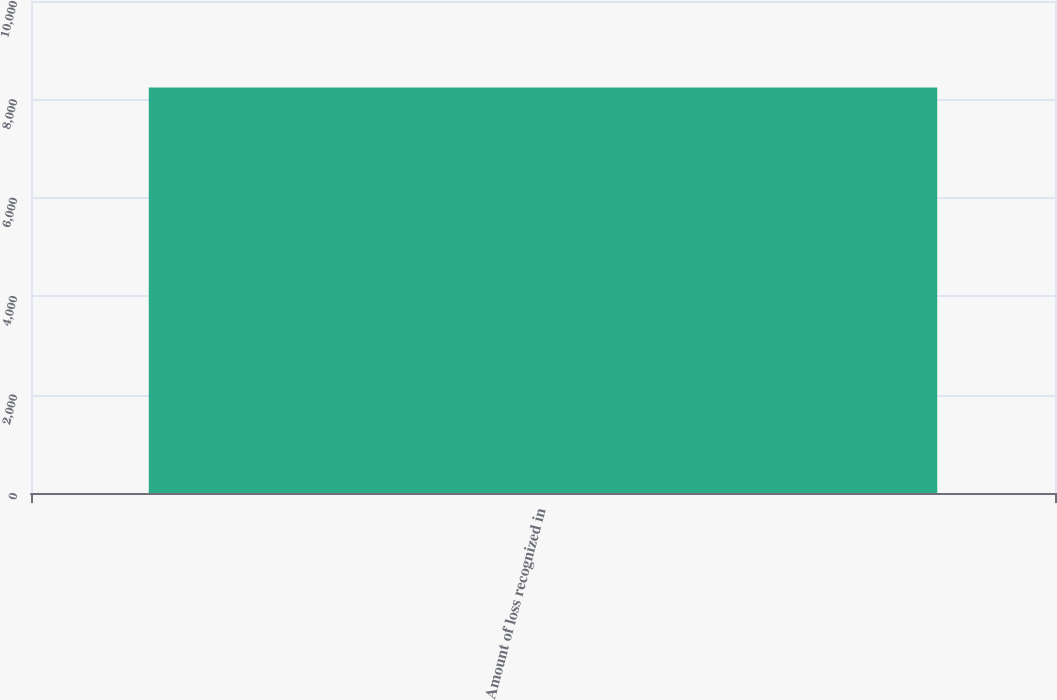Convert chart. <chart><loc_0><loc_0><loc_500><loc_500><bar_chart><fcel>Amount of loss recognized in<nl><fcel>8240<nl></chart> 